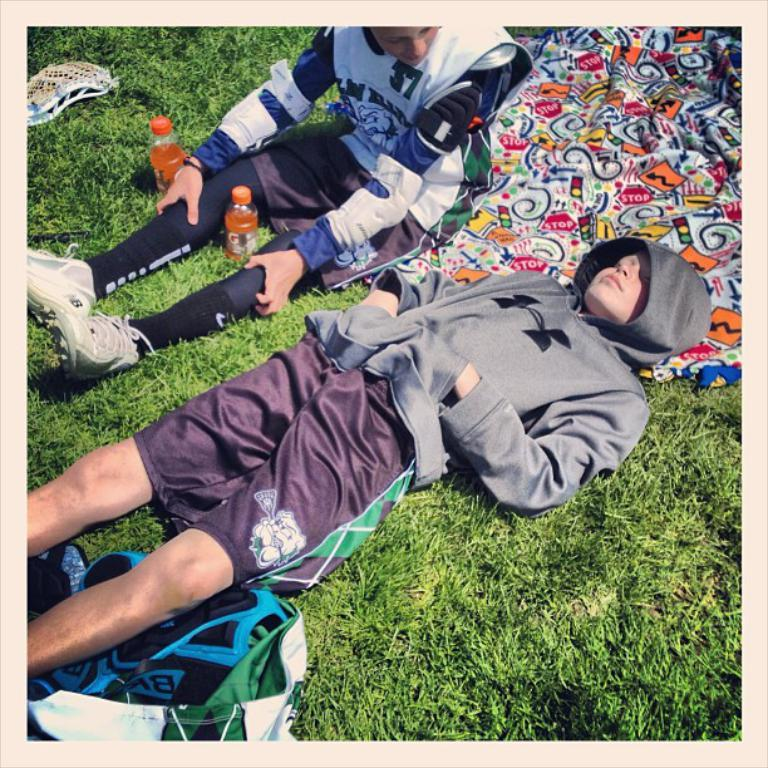How many people are present in the image? There are 2 people in the image. What are the positions of the people in the image? One person is lying on the grass, and the other person is sitting on the grass. What can be seen in the image besides the people? There is a bed sheet, 2 orange bottles, and a bag in the image. What type of soap is being used by the person sitting on the grass in the image? There is no soap present in the image, and no indication that any soap is being used. 